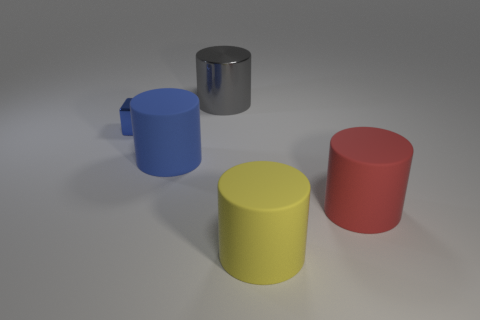What is the material of the big cylinder that is the same color as the metal block?
Ensure brevity in your answer.  Rubber. The other thing that is the same color as the tiny metal thing is what size?
Offer a terse response. Large. What number of other things are the same shape as the tiny blue shiny object?
Your answer should be compact. 0. Are there any other things that are the same color as the metallic block?
Ensure brevity in your answer.  Yes. There is a matte object right of the yellow rubber thing; is its size the same as the block?
Offer a very short reply. No. What is the color of the shiny object behind the object left of the large matte object that is behind the large red cylinder?
Give a very brief answer. Gray. What is the color of the small metallic block?
Your answer should be compact. Blue. Is the tiny object the same color as the large shiny cylinder?
Make the answer very short. No. Are the large thing in front of the red rubber cylinder and the large thing that is behind the small blue shiny block made of the same material?
Ensure brevity in your answer.  No. There is a yellow object that is the same shape as the red thing; what is it made of?
Offer a very short reply. Rubber. 